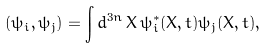<formula> <loc_0><loc_0><loc_500><loc_500>( \psi _ { i } , \psi _ { j } ) = \int d ^ { 3 n } \, X \, \psi _ { i } ^ { * } ( X , t ) \psi _ { j } ( X , t ) ,</formula> 